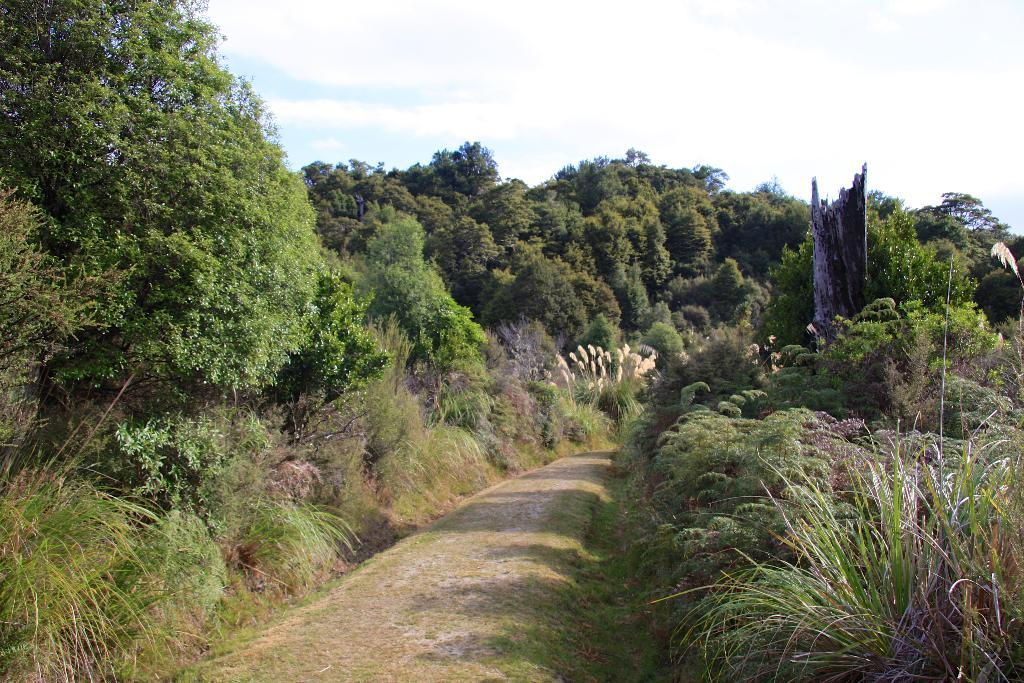What type of vegetation can be seen in the image? There are plants and trees in the image. What is covering the ground in the image? There is grass on the ground in the image. What can be seen in the background of the image? There is a trunk and the sky visible in the background of the image. What type of poison is being administered to the knee in the image? There is no poison or knee present in the image; it features plants, trees, grass, a trunk, and the sky. 